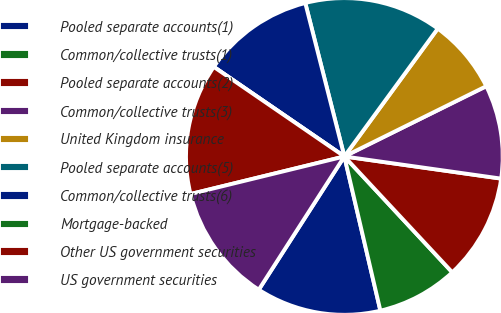Convert chart. <chart><loc_0><loc_0><loc_500><loc_500><pie_chart><fcel>Pooled separate accounts(1)<fcel>Common/collective trusts(1)<fcel>Pooled separate accounts(2)<fcel>Common/collective trusts(3)<fcel>United Kingdom insurance<fcel>Pooled separate accounts(5)<fcel>Common/collective trusts(6)<fcel>Mortgage-backed<fcel>Other US government securities<fcel>US government securities<nl><fcel>12.74%<fcel>8.28%<fcel>10.83%<fcel>9.55%<fcel>7.64%<fcel>14.01%<fcel>11.46%<fcel>0.0%<fcel>13.38%<fcel>12.1%<nl></chart> 